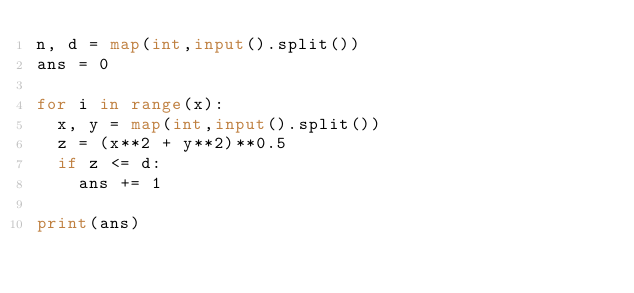Convert code to text. <code><loc_0><loc_0><loc_500><loc_500><_Python_>n, d = map(int,input().split())
ans = 0

for i in range(x):
  x, y = map(int,input().split())
  z = (x**2 + y**2)**0.5
  if z <= d:
    ans += 1

print(ans)</code> 